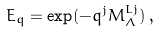Convert formula to latex. <formula><loc_0><loc_0><loc_500><loc_500>E _ { q } = \exp ( - q ^ { j } { M } _ { \Lambda } ^ { L j } ) \, ,</formula> 